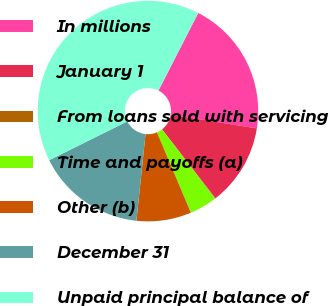<chart> <loc_0><loc_0><loc_500><loc_500><pie_chart><fcel>In millions<fcel>January 1<fcel>From loans sold with servicing<fcel>Time and payoffs (a)<fcel>Other (b)<fcel>December 31<fcel>Unpaid principal balance of<nl><fcel>19.97%<fcel>12.01%<fcel>0.07%<fcel>4.05%<fcel>8.03%<fcel>15.99%<fcel>39.87%<nl></chart> 